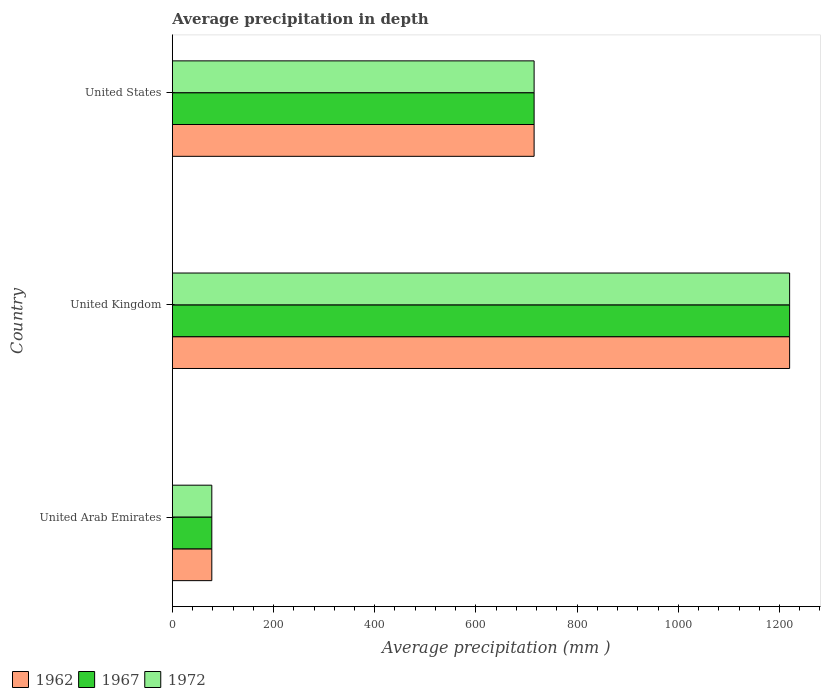How many groups of bars are there?
Your answer should be very brief. 3. Are the number of bars per tick equal to the number of legend labels?
Offer a very short reply. Yes. Are the number of bars on each tick of the Y-axis equal?
Your answer should be compact. Yes. How many bars are there on the 2nd tick from the top?
Your response must be concise. 3. What is the label of the 3rd group of bars from the top?
Your answer should be compact. United Arab Emirates. What is the average precipitation in 1972 in United Arab Emirates?
Your answer should be compact. 78. Across all countries, what is the maximum average precipitation in 1967?
Provide a succinct answer. 1220. Across all countries, what is the minimum average precipitation in 1967?
Offer a terse response. 78. In which country was the average precipitation in 1972 minimum?
Ensure brevity in your answer.  United Arab Emirates. What is the total average precipitation in 1967 in the graph?
Keep it short and to the point. 2013. What is the difference between the average precipitation in 1962 in United Arab Emirates and that in United States?
Offer a terse response. -637. What is the difference between the average precipitation in 1962 in United Kingdom and the average precipitation in 1967 in United Arab Emirates?
Give a very brief answer. 1142. What is the average average precipitation in 1972 per country?
Keep it short and to the point. 671. In how many countries, is the average precipitation in 1962 greater than 600 mm?
Your answer should be very brief. 2. What is the ratio of the average precipitation in 1967 in United Kingdom to that in United States?
Provide a short and direct response. 1.71. Is the average precipitation in 1962 in United Arab Emirates less than that in United Kingdom?
Give a very brief answer. Yes. Is the difference between the average precipitation in 1972 in United Arab Emirates and United States greater than the difference between the average precipitation in 1967 in United Arab Emirates and United States?
Offer a very short reply. No. What is the difference between the highest and the second highest average precipitation in 1967?
Give a very brief answer. 505. What is the difference between the highest and the lowest average precipitation in 1967?
Make the answer very short. 1142. In how many countries, is the average precipitation in 1967 greater than the average average precipitation in 1967 taken over all countries?
Your answer should be compact. 2. Is the sum of the average precipitation in 1967 in United Kingdom and United States greater than the maximum average precipitation in 1972 across all countries?
Make the answer very short. Yes. What does the 1st bar from the bottom in United Arab Emirates represents?
Ensure brevity in your answer.  1962. How many bars are there?
Provide a succinct answer. 9. How many countries are there in the graph?
Make the answer very short. 3. Does the graph contain any zero values?
Your answer should be very brief. No. Does the graph contain grids?
Your response must be concise. No. How many legend labels are there?
Offer a terse response. 3. What is the title of the graph?
Your response must be concise. Average precipitation in depth. What is the label or title of the X-axis?
Ensure brevity in your answer.  Average precipitation (mm ). What is the Average precipitation (mm ) in 1962 in United Arab Emirates?
Ensure brevity in your answer.  78. What is the Average precipitation (mm ) in 1967 in United Arab Emirates?
Your answer should be compact. 78. What is the Average precipitation (mm ) of 1972 in United Arab Emirates?
Provide a short and direct response. 78. What is the Average precipitation (mm ) in 1962 in United Kingdom?
Keep it short and to the point. 1220. What is the Average precipitation (mm ) in 1967 in United Kingdom?
Your response must be concise. 1220. What is the Average precipitation (mm ) of 1972 in United Kingdom?
Your answer should be very brief. 1220. What is the Average precipitation (mm ) in 1962 in United States?
Provide a succinct answer. 715. What is the Average precipitation (mm ) of 1967 in United States?
Your response must be concise. 715. What is the Average precipitation (mm ) of 1972 in United States?
Offer a very short reply. 715. Across all countries, what is the maximum Average precipitation (mm ) in 1962?
Your answer should be compact. 1220. Across all countries, what is the maximum Average precipitation (mm ) in 1967?
Make the answer very short. 1220. Across all countries, what is the maximum Average precipitation (mm ) in 1972?
Make the answer very short. 1220. Across all countries, what is the minimum Average precipitation (mm ) of 1972?
Provide a short and direct response. 78. What is the total Average precipitation (mm ) in 1962 in the graph?
Offer a very short reply. 2013. What is the total Average precipitation (mm ) of 1967 in the graph?
Provide a succinct answer. 2013. What is the total Average precipitation (mm ) in 1972 in the graph?
Make the answer very short. 2013. What is the difference between the Average precipitation (mm ) in 1962 in United Arab Emirates and that in United Kingdom?
Your response must be concise. -1142. What is the difference between the Average precipitation (mm ) of 1967 in United Arab Emirates and that in United Kingdom?
Provide a short and direct response. -1142. What is the difference between the Average precipitation (mm ) of 1972 in United Arab Emirates and that in United Kingdom?
Your answer should be compact. -1142. What is the difference between the Average precipitation (mm ) in 1962 in United Arab Emirates and that in United States?
Provide a short and direct response. -637. What is the difference between the Average precipitation (mm ) in 1967 in United Arab Emirates and that in United States?
Give a very brief answer. -637. What is the difference between the Average precipitation (mm ) of 1972 in United Arab Emirates and that in United States?
Offer a terse response. -637. What is the difference between the Average precipitation (mm ) in 1962 in United Kingdom and that in United States?
Make the answer very short. 505. What is the difference between the Average precipitation (mm ) in 1967 in United Kingdom and that in United States?
Your answer should be compact. 505. What is the difference between the Average precipitation (mm ) of 1972 in United Kingdom and that in United States?
Your answer should be compact. 505. What is the difference between the Average precipitation (mm ) in 1962 in United Arab Emirates and the Average precipitation (mm ) in 1967 in United Kingdom?
Offer a very short reply. -1142. What is the difference between the Average precipitation (mm ) of 1962 in United Arab Emirates and the Average precipitation (mm ) of 1972 in United Kingdom?
Offer a terse response. -1142. What is the difference between the Average precipitation (mm ) in 1967 in United Arab Emirates and the Average precipitation (mm ) in 1972 in United Kingdom?
Keep it short and to the point. -1142. What is the difference between the Average precipitation (mm ) in 1962 in United Arab Emirates and the Average precipitation (mm ) in 1967 in United States?
Give a very brief answer. -637. What is the difference between the Average precipitation (mm ) in 1962 in United Arab Emirates and the Average precipitation (mm ) in 1972 in United States?
Give a very brief answer. -637. What is the difference between the Average precipitation (mm ) of 1967 in United Arab Emirates and the Average precipitation (mm ) of 1972 in United States?
Offer a terse response. -637. What is the difference between the Average precipitation (mm ) of 1962 in United Kingdom and the Average precipitation (mm ) of 1967 in United States?
Offer a very short reply. 505. What is the difference between the Average precipitation (mm ) of 1962 in United Kingdom and the Average precipitation (mm ) of 1972 in United States?
Keep it short and to the point. 505. What is the difference between the Average precipitation (mm ) of 1967 in United Kingdom and the Average precipitation (mm ) of 1972 in United States?
Offer a terse response. 505. What is the average Average precipitation (mm ) in 1962 per country?
Ensure brevity in your answer.  671. What is the average Average precipitation (mm ) of 1967 per country?
Ensure brevity in your answer.  671. What is the average Average precipitation (mm ) in 1972 per country?
Ensure brevity in your answer.  671. What is the difference between the Average precipitation (mm ) in 1962 and Average precipitation (mm ) in 1972 in United Kingdom?
Offer a very short reply. 0. What is the difference between the Average precipitation (mm ) in 1962 and Average precipitation (mm ) in 1967 in United States?
Offer a very short reply. 0. What is the difference between the Average precipitation (mm ) of 1967 and Average precipitation (mm ) of 1972 in United States?
Your answer should be very brief. 0. What is the ratio of the Average precipitation (mm ) in 1962 in United Arab Emirates to that in United Kingdom?
Keep it short and to the point. 0.06. What is the ratio of the Average precipitation (mm ) of 1967 in United Arab Emirates to that in United Kingdom?
Provide a short and direct response. 0.06. What is the ratio of the Average precipitation (mm ) in 1972 in United Arab Emirates to that in United Kingdom?
Your answer should be very brief. 0.06. What is the ratio of the Average precipitation (mm ) of 1962 in United Arab Emirates to that in United States?
Give a very brief answer. 0.11. What is the ratio of the Average precipitation (mm ) of 1967 in United Arab Emirates to that in United States?
Ensure brevity in your answer.  0.11. What is the ratio of the Average precipitation (mm ) in 1972 in United Arab Emirates to that in United States?
Your answer should be compact. 0.11. What is the ratio of the Average precipitation (mm ) of 1962 in United Kingdom to that in United States?
Make the answer very short. 1.71. What is the ratio of the Average precipitation (mm ) in 1967 in United Kingdom to that in United States?
Your answer should be compact. 1.71. What is the ratio of the Average precipitation (mm ) in 1972 in United Kingdom to that in United States?
Your answer should be compact. 1.71. What is the difference between the highest and the second highest Average precipitation (mm ) of 1962?
Your response must be concise. 505. What is the difference between the highest and the second highest Average precipitation (mm ) in 1967?
Your answer should be compact. 505. What is the difference between the highest and the second highest Average precipitation (mm ) of 1972?
Provide a short and direct response. 505. What is the difference between the highest and the lowest Average precipitation (mm ) of 1962?
Provide a short and direct response. 1142. What is the difference between the highest and the lowest Average precipitation (mm ) of 1967?
Provide a short and direct response. 1142. What is the difference between the highest and the lowest Average precipitation (mm ) of 1972?
Your answer should be very brief. 1142. 